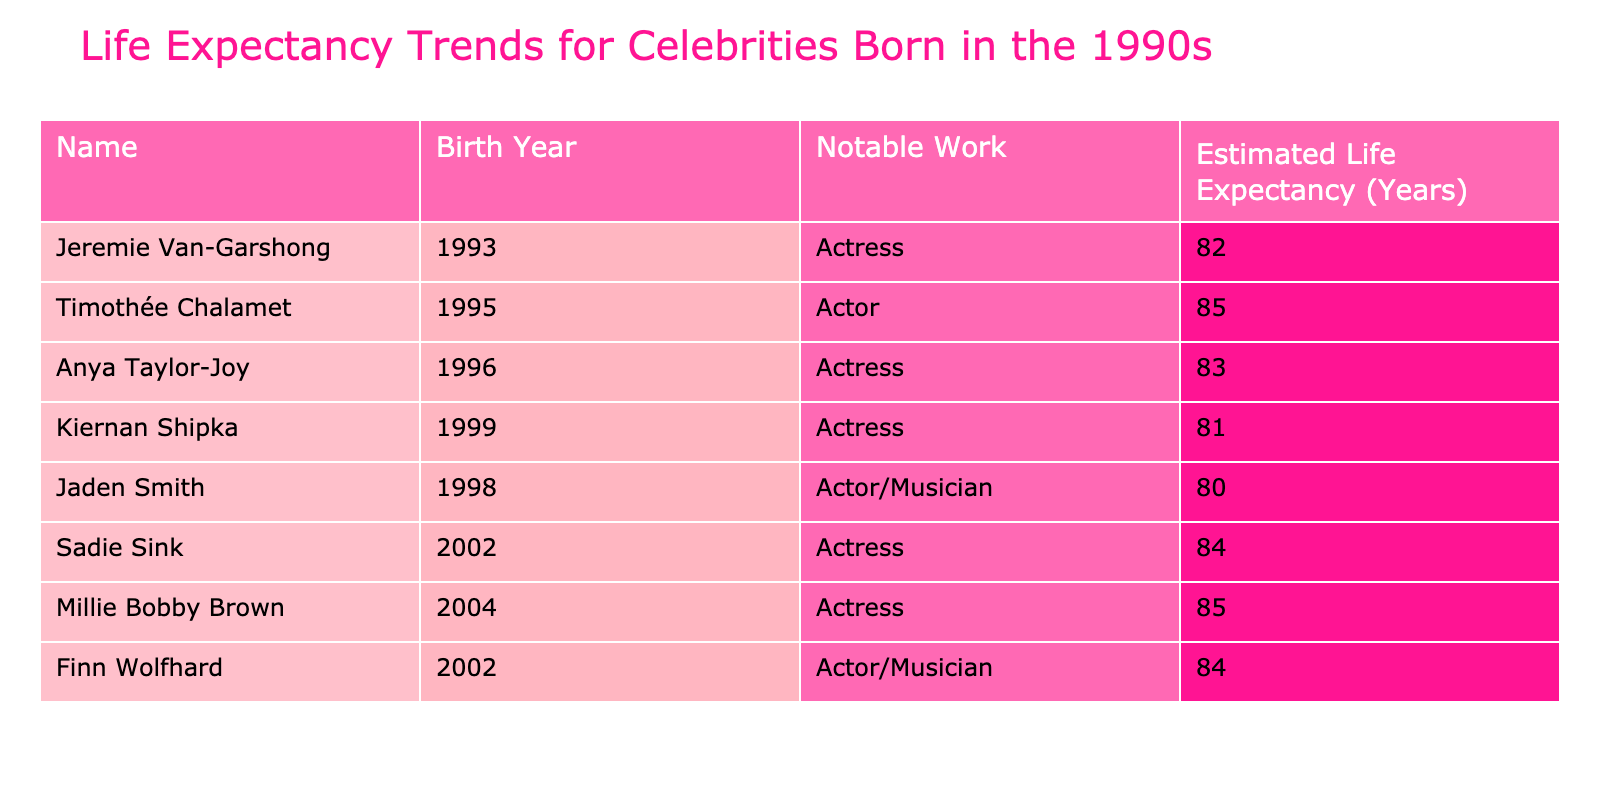What is the estimated life expectancy of Jeremie Van-Garshong? The table lists Jeremie Van-Garshong's estimated life expectancy as 82 years.
Answer: 82 Which celebrity has the highest estimated life expectancy? By comparing the values in the table, Timothée Chalamet has the highest estimated life expectancy at 85 years.
Answer: 85 Are there any celebrities in the table with an estimated life expectancy below 82 years? The table shows Jaden Smith with an estimated life expectancy of 80 years and Kiernan Shipka at 81 years, so yes, there are celebrities below 82 years.
Answer: Yes What is the average estimated life expectancy of the celebrities born in the 1990s? The estimated life expectancy values for the celebrities born in the 1990s are: Jeremie Van-Garshong (82), Timothée Chalamet (85), Anya Taylor-Joy (83), Kiernan Shipka (81), and Jaden Smith (80). The sum is 411, and dividing by 5 gives an average of 82.2 years.
Answer: 82.2 Is Anya Taylor-Joy's estimated life expectancy higher than that of Kiernan Shipka? Anya Taylor-Joy's estimated life expectancy is 83 years, while Kiernan Shipka's is 81 years, so Anya Taylor-Joy's is indeed higher.
Answer: Yes What is the difference in estimated life expectancy between Millie Bobby Brown and Jaden Smith? Millie Bobby Brown has an estimated life expectancy of 85 years, while Jaden Smith's is 80 years. The difference (85 - 80) is 5 years.
Answer: 5 How many celebrities have an estimated life expectancy of 84 years? The table indicates that there are two celebrities with an estimated life expectancy of 84 years: Sadie Sink and Finn Wolfhard.
Answer: 2 What is the total estimated life expectancy of all celebrities listed in the table? We summarize the estimated life expectancies: Jeremie Van-Garshong (82), Timothée Chalamet (85), Anya Taylor-Joy (83), Kiernan Shipka (81), Jaden Smith (80), Sadie Sink (84), Millie Bobby Brown (85), and Finn Wolfhard (84). Summing these values gives a total of  82 + 85 + 83 + 81 + 80 + 84 + 85 + 84 = 664 years.
Answer: 664 Which is the second-highest estimated life expectancy among the celebrities born in the 1990s? The highest is Timothée Chalamet at 85 years, the second-highest is Anya Taylor-Joy at 83 years.
Answer: 83 